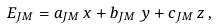Convert formula to latex. <formula><loc_0><loc_0><loc_500><loc_500>E _ { J M } = a _ { J M } \, x + b _ { J M } \, y + c _ { J M } \, z \, ,</formula> 